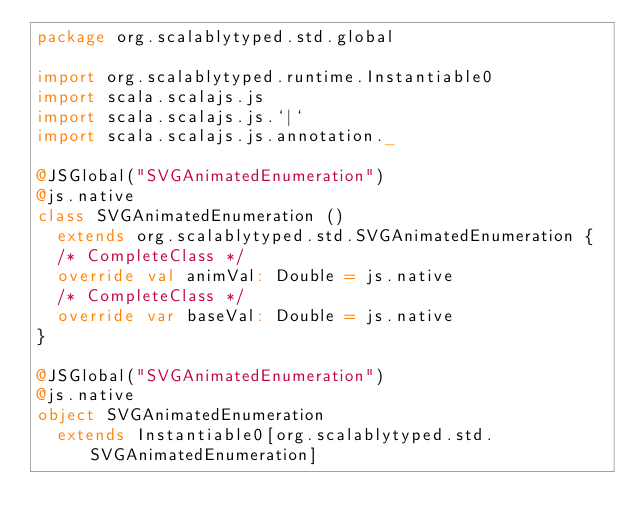<code> <loc_0><loc_0><loc_500><loc_500><_Scala_>package org.scalablytyped.std.global

import org.scalablytyped.runtime.Instantiable0
import scala.scalajs.js
import scala.scalajs.js.`|`
import scala.scalajs.js.annotation._

@JSGlobal("SVGAnimatedEnumeration")
@js.native
class SVGAnimatedEnumeration ()
  extends org.scalablytyped.std.SVGAnimatedEnumeration {
  /* CompleteClass */
  override val animVal: Double = js.native
  /* CompleteClass */
  override var baseVal: Double = js.native
}

@JSGlobal("SVGAnimatedEnumeration")
@js.native
object SVGAnimatedEnumeration
  extends Instantiable0[org.scalablytyped.std.SVGAnimatedEnumeration]

</code> 